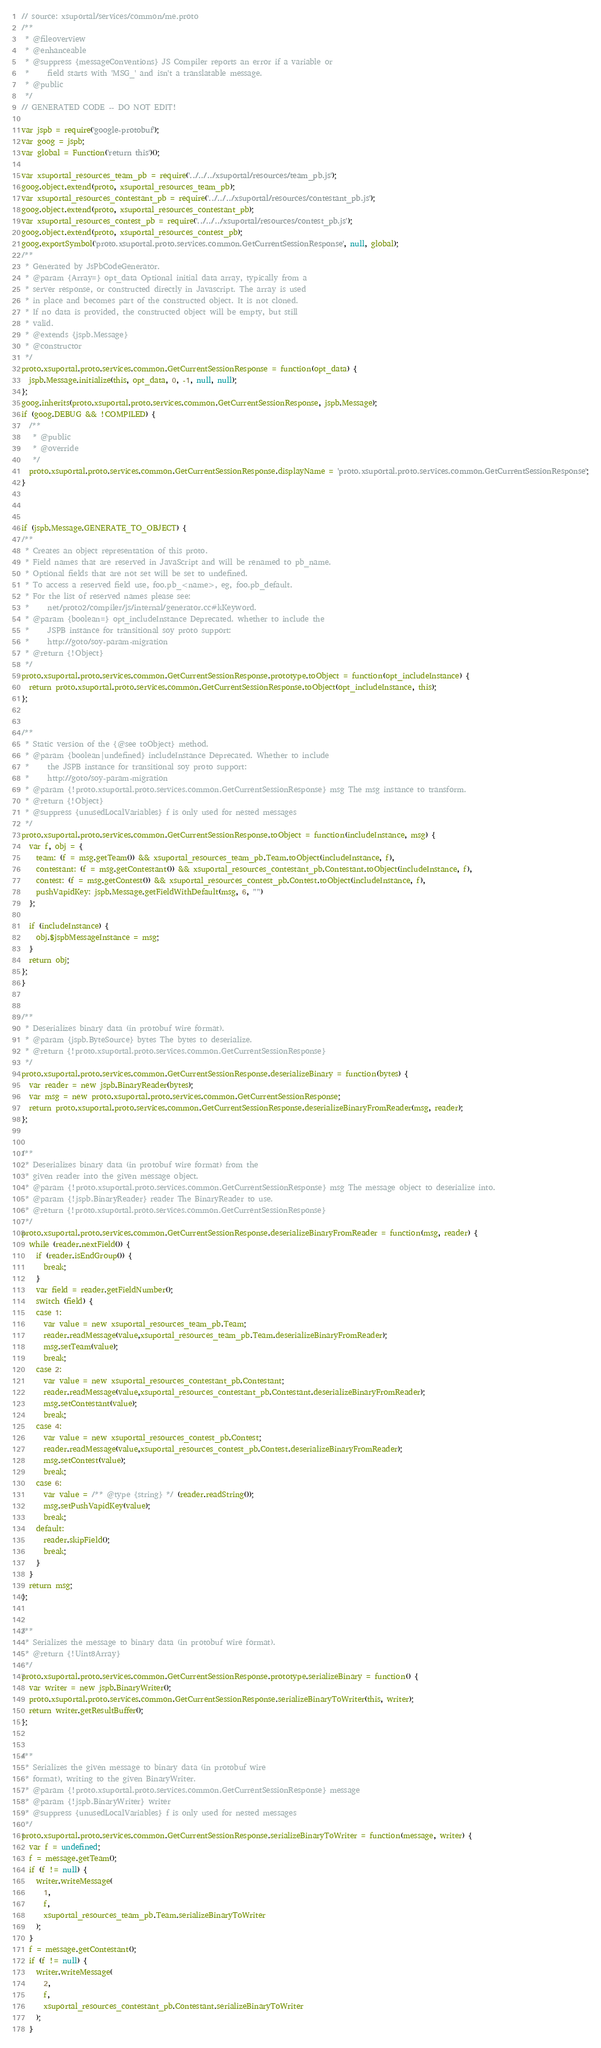Convert code to text. <code><loc_0><loc_0><loc_500><loc_500><_JavaScript_>// source: xsuportal/services/common/me.proto
/**
 * @fileoverview
 * @enhanceable
 * @suppress {messageConventions} JS Compiler reports an error if a variable or
 *     field starts with 'MSG_' and isn't a translatable message.
 * @public
 */
// GENERATED CODE -- DO NOT EDIT!

var jspb = require('google-protobuf');
var goog = jspb;
var global = Function('return this')();

var xsuportal_resources_team_pb = require('../../../xsuportal/resources/team_pb.js');
goog.object.extend(proto, xsuportal_resources_team_pb);
var xsuportal_resources_contestant_pb = require('../../../xsuportal/resources/contestant_pb.js');
goog.object.extend(proto, xsuportal_resources_contestant_pb);
var xsuportal_resources_contest_pb = require('../../../xsuportal/resources/contest_pb.js');
goog.object.extend(proto, xsuportal_resources_contest_pb);
goog.exportSymbol('proto.xsuportal.proto.services.common.GetCurrentSessionResponse', null, global);
/**
 * Generated by JsPbCodeGenerator.
 * @param {Array=} opt_data Optional initial data array, typically from a
 * server response, or constructed directly in Javascript. The array is used
 * in place and becomes part of the constructed object. It is not cloned.
 * If no data is provided, the constructed object will be empty, but still
 * valid.
 * @extends {jspb.Message}
 * @constructor
 */
proto.xsuportal.proto.services.common.GetCurrentSessionResponse = function(opt_data) {
  jspb.Message.initialize(this, opt_data, 0, -1, null, null);
};
goog.inherits(proto.xsuportal.proto.services.common.GetCurrentSessionResponse, jspb.Message);
if (goog.DEBUG && !COMPILED) {
  /**
   * @public
   * @override
   */
  proto.xsuportal.proto.services.common.GetCurrentSessionResponse.displayName = 'proto.xsuportal.proto.services.common.GetCurrentSessionResponse';
}



if (jspb.Message.GENERATE_TO_OBJECT) {
/**
 * Creates an object representation of this proto.
 * Field names that are reserved in JavaScript and will be renamed to pb_name.
 * Optional fields that are not set will be set to undefined.
 * To access a reserved field use, foo.pb_<name>, eg, foo.pb_default.
 * For the list of reserved names please see:
 *     net/proto2/compiler/js/internal/generator.cc#kKeyword.
 * @param {boolean=} opt_includeInstance Deprecated. whether to include the
 *     JSPB instance for transitional soy proto support:
 *     http://goto/soy-param-migration
 * @return {!Object}
 */
proto.xsuportal.proto.services.common.GetCurrentSessionResponse.prototype.toObject = function(opt_includeInstance) {
  return proto.xsuportal.proto.services.common.GetCurrentSessionResponse.toObject(opt_includeInstance, this);
};


/**
 * Static version of the {@see toObject} method.
 * @param {boolean|undefined} includeInstance Deprecated. Whether to include
 *     the JSPB instance for transitional soy proto support:
 *     http://goto/soy-param-migration
 * @param {!proto.xsuportal.proto.services.common.GetCurrentSessionResponse} msg The msg instance to transform.
 * @return {!Object}
 * @suppress {unusedLocalVariables} f is only used for nested messages
 */
proto.xsuportal.proto.services.common.GetCurrentSessionResponse.toObject = function(includeInstance, msg) {
  var f, obj = {
    team: (f = msg.getTeam()) && xsuportal_resources_team_pb.Team.toObject(includeInstance, f),
    contestant: (f = msg.getContestant()) && xsuportal_resources_contestant_pb.Contestant.toObject(includeInstance, f),
    contest: (f = msg.getContest()) && xsuportal_resources_contest_pb.Contest.toObject(includeInstance, f),
    pushVapidKey: jspb.Message.getFieldWithDefault(msg, 6, "")
  };

  if (includeInstance) {
    obj.$jspbMessageInstance = msg;
  }
  return obj;
};
}


/**
 * Deserializes binary data (in protobuf wire format).
 * @param {jspb.ByteSource} bytes The bytes to deserialize.
 * @return {!proto.xsuportal.proto.services.common.GetCurrentSessionResponse}
 */
proto.xsuportal.proto.services.common.GetCurrentSessionResponse.deserializeBinary = function(bytes) {
  var reader = new jspb.BinaryReader(bytes);
  var msg = new proto.xsuportal.proto.services.common.GetCurrentSessionResponse;
  return proto.xsuportal.proto.services.common.GetCurrentSessionResponse.deserializeBinaryFromReader(msg, reader);
};


/**
 * Deserializes binary data (in protobuf wire format) from the
 * given reader into the given message object.
 * @param {!proto.xsuportal.proto.services.common.GetCurrentSessionResponse} msg The message object to deserialize into.
 * @param {!jspb.BinaryReader} reader The BinaryReader to use.
 * @return {!proto.xsuportal.proto.services.common.GetCurrentSessionResponse}
 */
proto.xsuportal.proto.services.common.GetCurrentSessionResponse.deserializeBinaryFromReader = function(msg, reader) {
  while (reader.nextField()) {
    if (reader.isEndGroup()) {
      break;
    }
    var field = reader.getFieldNumber();
    switch (field) {
    case 1:
      var value = new xsuportal_resources_team_pb.Team;
      reader.readMessage(value,xsuportal_resources_team_pb.Team.deserializeBinaryFromReader);
      msg.setTeam(value);
      break;
    case 2:
      var value = new xsuportal_resources_contestant_pb.Contestant;
      reader.readMessage(value,xsuportal_resources_contestant_pb.Contestant.deserializeBinaryFromReader);
      msg.setContestant(value);
      break;
    case 4:
      var value = new xsuportal_resources_contest_pb.Contest;
      reader.readMessage(value,xsuportal_resources_contest_pb.Contest.deserializeBinaryFromReader);
      msg.setContest(value);
      break;
    case 6:
      var value = /** @type {string} */ (reader.readString());
      msg.setPushVapidKey(value);
      break;
    default:
      reader.skipField();
      break;
    }
  }
  return msg;
};


/**
 * Serializes the message to binary data (in protobuf wire format).
 * @return {!Uint8Array}
 */
proto.xsuportal.proto.services.common.GetCurrentSessionResponse.prototype.serializeBinary = function() {
  var writer = new jspb.BinaryWriter();
  proto.xsuportal.proto.services.common.GetCurrentSessionResponse.serializeBinaryToWriter(this, writer);
  return writer.getResultBuffer();
};


/**
 * Serializes the given message to binary data (in protobuf wire
 * format), writing to the given BinaryWriter.
 * @param {!proto.xsuportal.proto.services.common.GetCurrentSessionResponse} message
 * @param {!jspb.BinaryWriter} writer
 * @suppress {unusedLocalVariables} f is only used for nested messages
 */
proto.xsuportal.proto.services.common.GetCurrentSessionResponse.serializeBinaryToWriter = function(message, writer) {
  var f = undefined;
  f = message.getTeam();
  if (f != null) {
    writer.writeMessage(
      1,
      f,
      xsuportal_resources_team_pb.Team.serializeBinaryToWriter
    );
  }
  f = message.getContestant();
  if (f != null) {
    writer.writeMessage(
      2,
      f,
      xsuportal_resources_contestant_pb.Contestant.serializeBinaryToWriter
    );
  }</code> 